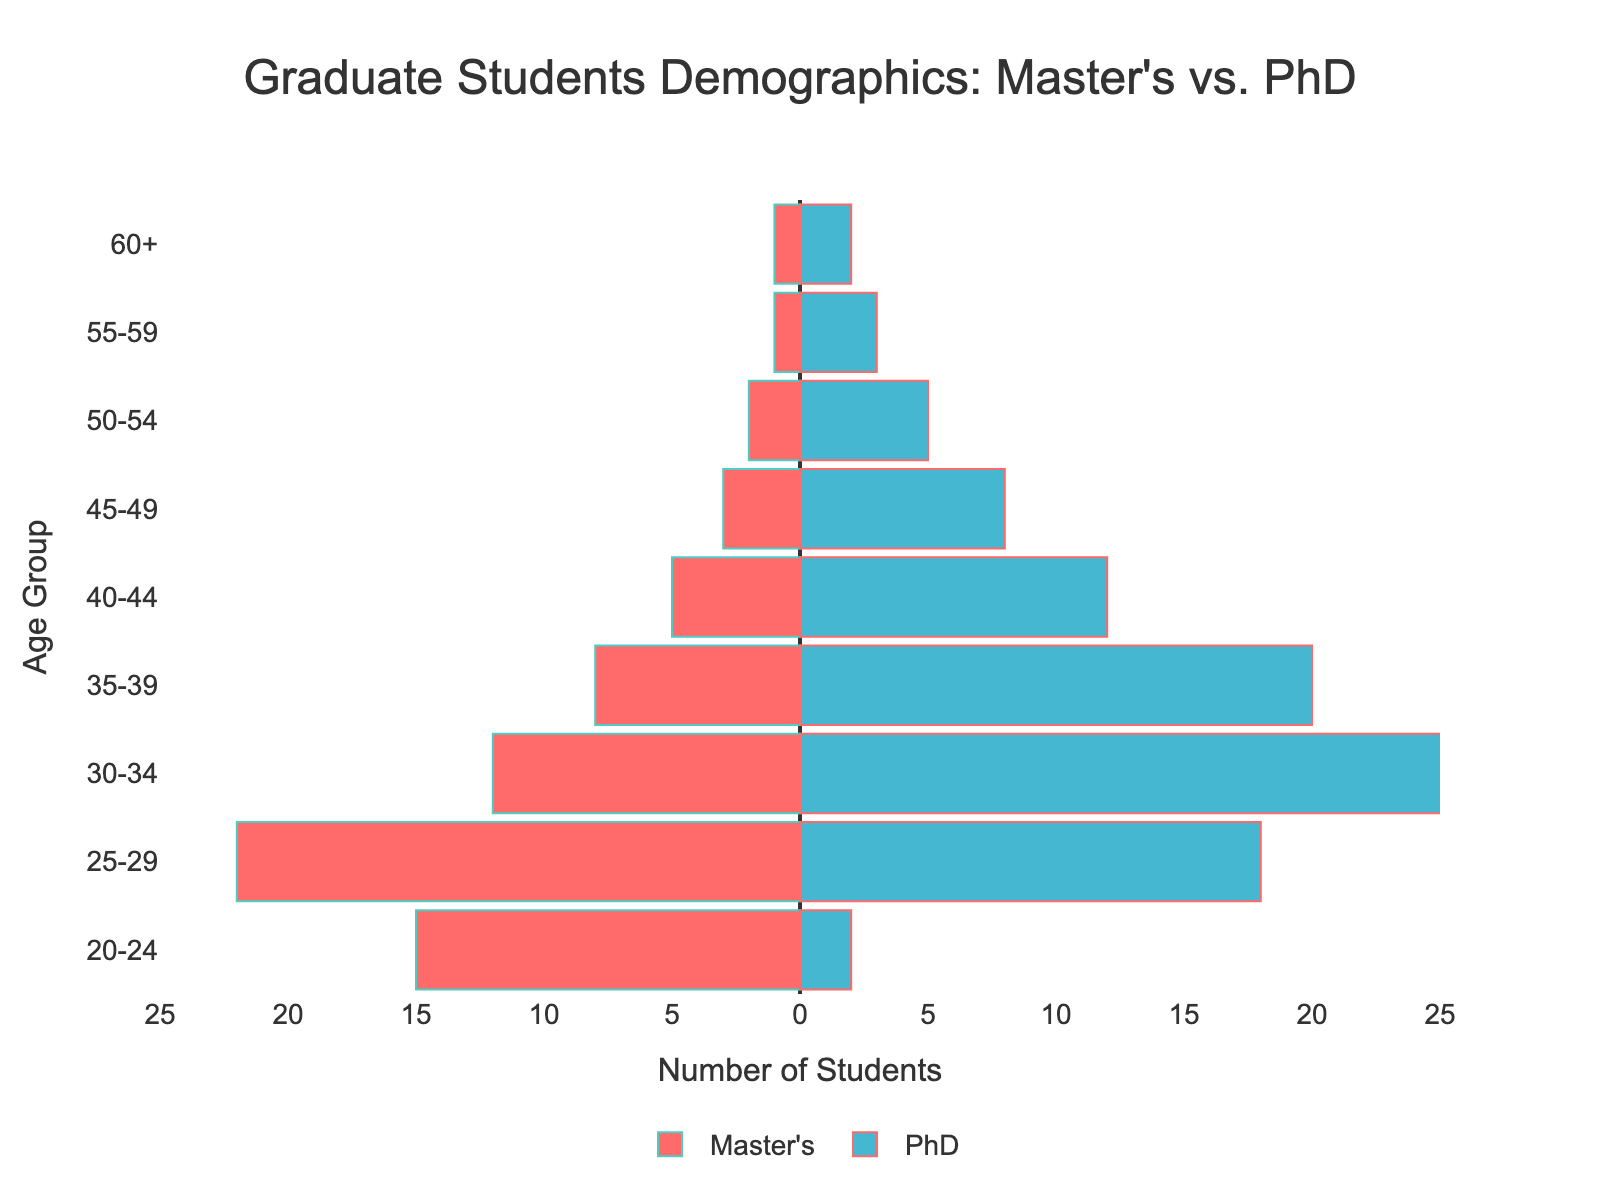What is the title of the figure? The title is located at the top center of the figure, written in larger font size as "Graduate Students Demographics: Master's vs. PhD".
Answer: Graduate Students Demographics: Master's vs. PhD How many students are aged 25-29? To find the total number of students in the 25-29 age group, sum the Master's and PhD students in that age range (22 + 18).
Answer: 40 Which age group has the most PhD students? By comparing the height of the bars for PhD students, we see that the 30-34 age group has the largest bar indicating the most PhD students.
Answer: 30-34 Comparing the age groups 35-39 and 45-49, which one has more Master's students? The bar for Master's students in the 35-39 age group has a length that represents 8 students, whereas the 45-49 age group's bar represents 3 students. Therefore, the 35-39 age group has more Master's students.
Answer: 35-39 What is the total number of students aged 20-24? Sum the number of Master's and PhD students in the 20-24 age group (15 + 2).
Answer: 17 Are there more Master's or PhD students in the 40-44 age group? Compare the lengths of the bars for 40-44 age group: the Master's bar represents 5 students and the PhD bar represents 12 students. Therefore, there are more PhD students.
Answer: PhD How many age groups have more than 10 PhD students? Count the age groups where the length of the PhD bar represents more than 10 students: 25-29, 30-34, 35-39, 40-44. There are 4 such age groups.
Answer: 4 What is the difference in the number of Master's and PhD students in the 50-54 age group? Subtract the number of PhD students from the number of Master's students in the 50-54 age group (2 - 5).
Answer: -3 Which age group has the lowest number of total students? Add the Master's and PhD students for each age group and compare: the 60+ age group has the lowest total number (\(1 + 2 = 3\)).
Answer: 60+ What percentage of the total students aged 25-29 are PhD students? First, find the total number of students aged 25-29, which is 40. Then, divide the number of PhD students by the total (18/40) and multiply by 100 to get the percentage.
Answer: 45% 